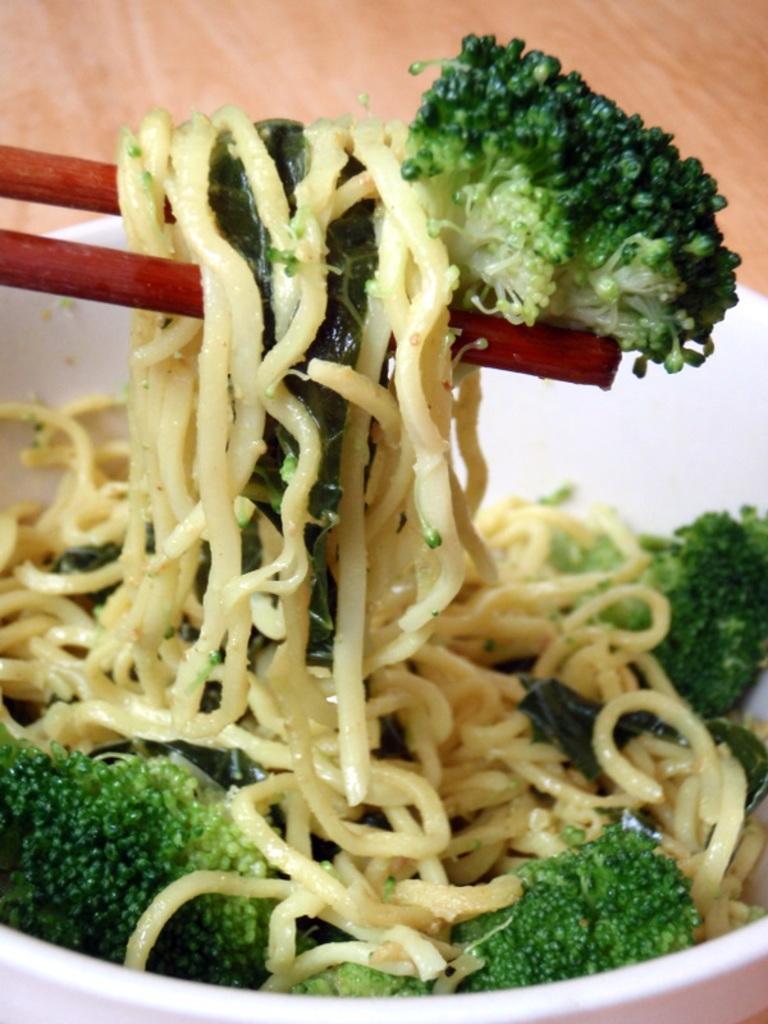In one or two sentences, can you explain what this image depicts? In the center of the image we can see noodles and broccoli in bowl placed on the table and we can also see chop sticks. 